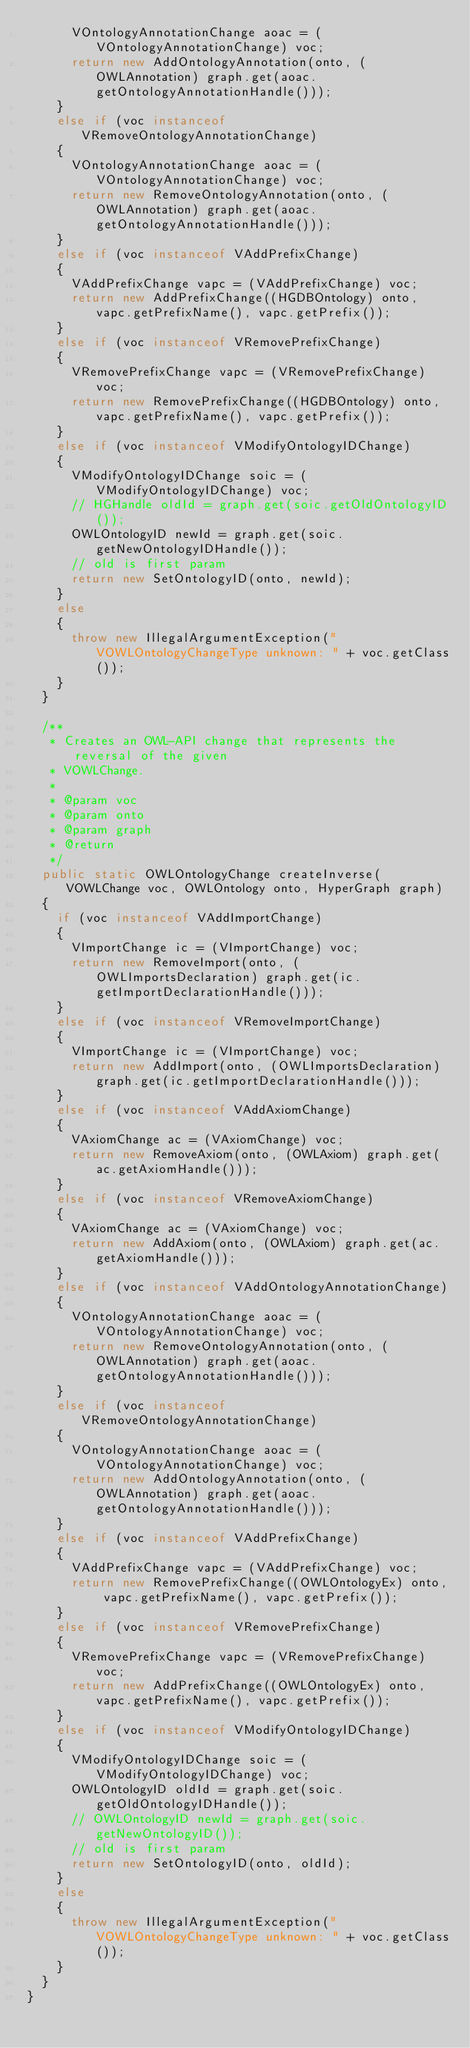<code> <loc_0><loc_0><loc_500><loc_500><_Java_>			VOntologyAnnotationChange aoac = (VOntologyAnnotationChange) voc;
			return new AddOntologyAnnotation(onto, (OWLAnnotation) graph.get(aoac.getOntologyAnnotationHandle()));
		}
		else if (voc instanceof VRemoveOntologyAnnotationChange)
		{
			VOntologyAnnotationChange aoac = (VOntologyAnnotationChange) voc;
			return new RemoveOntologyAnnotation(onto, (OWLAnnotation) graph.get(aoac.getOntologyAnnotationHandle()));
		}
		else if (voc instanceof VAddPrefixChange)
		{
			VAddPrefixChange vapc = (VAddPrefixChange) voc;
			return new AddPrefixChange((HGDBOntology) onto, vapc.getPrefixName(), vapc.getPrefix());
		}
		else if (voc instanceof VRemovePrefixChange)
		{
			VRemovePrefixChange vapc = (VRemovePrefixChange) voc;
			return new RemovePrefixChange((HGDBOntology) onto, vapc.getPrefixName(), vapc.getPrefix());
		}
		else if (voc instanceof VModifyOntologyIDChange)
		{
			VModifyOntologyIDChange soic = (VModifyOntologyIDChange) voc;
			// HGHandle oldId = graph.get(soic.getOldOntologyID());
			OWLOntologyID newId = graph.get(soic.getNewOntologyIDHandle());
			// old is first param
			return new SetOntologyID(onto, newId);
		}
		else
		{
			throw new IllegalArgumentException("VOWLOntologyChangeType unknown: " + voc.getClass());
		}
	}

	/**
	 * Creates an OWL-API change that represents the reversal of the given
	 * VOWLChange.
	 * 
	 * @param voc
	 * @param onto
	 * @param graph
	 * @return
	 */
	public static OWLOntologyChange createInverse(VOWLChange voc, OWLOntology onto, HyperGraph graph)
	{
		if (voc instanceof VAddImportChange)
		{
			VImportChange ic = (VImportChange) voc;
			return new RemoveImport(onto, (OWLImportsDeclaration) graph.get(ic.getImportDeclarationHandle()));
		}
		else if (voc instanceof VRemoveImportChange)
		{
			VImportChange ic = (VImportChange) voc;
			return new AddImport(onto, (OWLImportsDeclaration) graph.get(ic.getImportDeclarationHandle()));
		}
		else if (voc instanceof VAddAxiomChange)
		{
			VAxiomChange ac = (VAxiomChange) voc;
			return new RemoveAxiom(onto, (OWLAxiom) graph.get(ac.getAxiomHandle()));
		}
		else if (voc instanceof VRemoveAxiomChange)
		{
			VAxiomChange ac = (VAxiomChange) voc;
			return new AddAxiom(onto, (OWLAxiom) graph.get(ac.getAxiomHandle()));
		}
		else if (voc instanceof VAddOntologyAnnotationChange)
		{
			VOntologyAnnotationChange aoac = (VOntologyAnnotationChange) voc;
			return new RemoveOntologyAnnotation(onto, (OWLAnnotation) graph.get(aoac.getOntologyAnnotationHandle()));
		}
		else if (voc instanceof VRemoveOntologyAnnotationChange)
		{
			VOntologyAnnotationChange aoac = (VOntologyAnnotationChange) voc;
			return new AddOntologyAnnotation(onto, (OWLAnnotation) graph.get(aoac.getOntologyAnnotationHandle()));
		}
		else if (voc instanceof VAddPrefixChange)
		{
			VAddPrefixChange vapc = (VAddPrefixChange) voc;
			return new RemovePrefixChange((OWLOntologyEx) onto, vapc.getPrefixName(), vapc.getPrefix());
		}
		else if (voc instanceof VRemovePrefixChange)
		{
			VRemovePrefixChange vapc = (VRemovePrefixChange) voc;
			return new AddPrefixChange((OWLOntologyEx) onto, vapc.getPrefixName(), vapc.getPrefix());
		}
		else if (voc instanceof VModifyOntologyIDChange)
		{
			VModifyOntologyIDChange soic = (VModifyOntologyIDChange) voc;
			OWLOntologyID oldId = graph.get(soic.getOldOntologyIDHandle());
			// OWLOntologyID newId = graph.get(soic.getNewOntologyID());
			// old is first param
			return new SetOntologyID(onto, oldId);
		}
		else
		{
			throw new IllegalArgumentException("VOWLOntologyChangeType unknown: " + voc.getClass());
		}
	}
}
</code> 